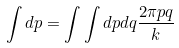<formula> <loc_0><loc_0><loc_500><loc_500>\int d { p } = \int \int d p d q \frac { 2 \pi p q } k</formula> 